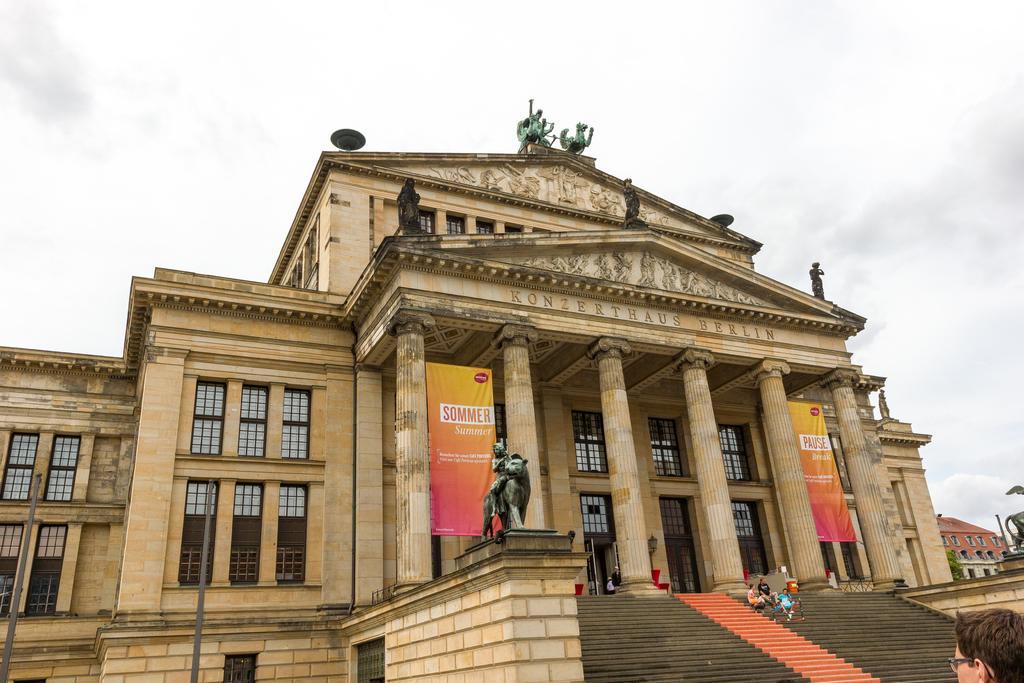Please provide a concise description of this image. In this image we can see buildings, sculptures, poles, pillars, banners, and few people. In the background there is sky with clouds. 